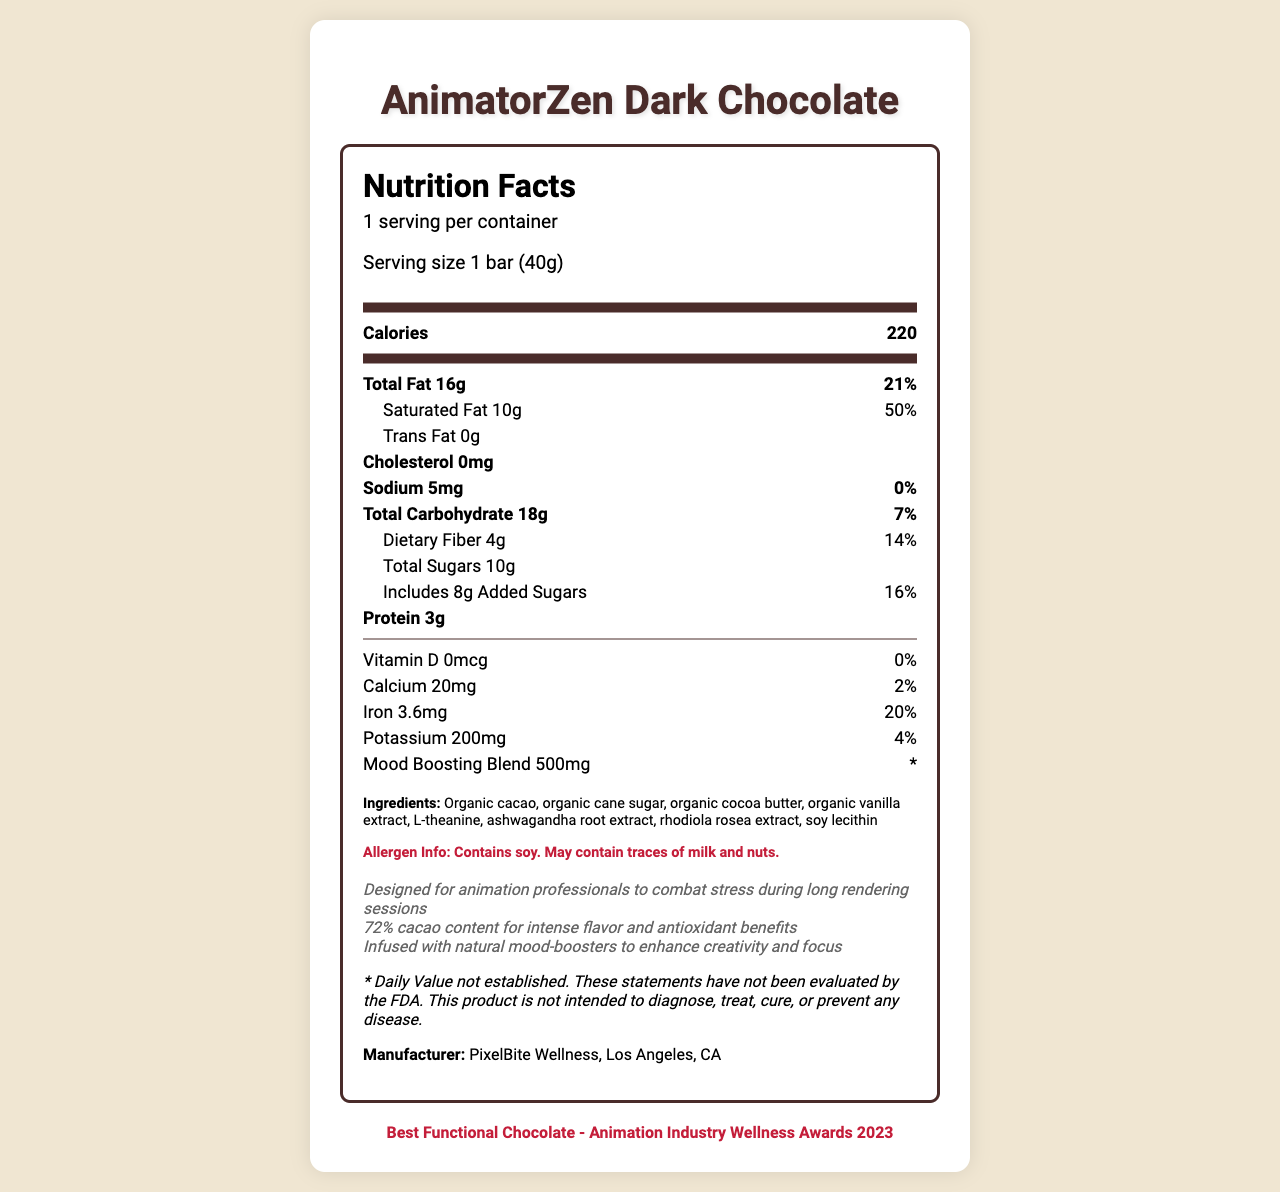what is the serving size of AnimatorZen Dark Chocolate? The serving size is clearly stated at the beginning of the document.
Answer: 1 bar (40g) how many calories does one serving of AnimatorZen Dark Chocolate contain? The document shows that each serving contains 220 calories.
Answer: 220 what is the total fat content per serving? The document specifies that the total fat content per serving is 16g.
Answer: 16g what percentage of the daily value does saturated fat contribute? It is highlighted in the document that the saturated fat contributes 50% to the daily value.
Answer: 50% what is the sodium content in AnimatorZen Dark Chocolate? The sodium content per serving is 5mg, according to the document.
Answer: 5mg what is the iron daily value percentage provided per serving? The document states that the iron content contributes 20% to the daily value.
Answer: 20% which ingredients in AnimatorZen Dark Chocolate are organic? A. Cacao B. Cane Sugar C. Cocoa Butter D. All of the above The ingredients list mentions that cacao, cane sugar, and cocoa butter are all organic.
Answer: D. All of the above what is the percentage of the daily value of calcium per serving? A. 10% B. 2% C. 5% D. 0% The document notes that the calcium content is 20mg, contributing 2% to the daily value.
Answer: B. 2% does AnimatorZen Dark Chocolate contain any trans fat? The document explicitly states that there is 0g of trans fat.
Answer: No is the product designed to combat stress during long rendering sessions? One of the special notes explicitly mentions that the product is designed for animation professionals to combat stress during long rendering sessions.
Answer: Yes what is the main purpose of AnimatorZen Dark Chocolate? The special notes highlight that the chocolate is infused with natural mood-boosters for stress relief and is designed for animation professionals.
Answer: The main purpose is to provide stress relief and enhance creativity and focus for animation professionals. what is the manufacturer's address for AnimatorZen Dark Chocolate? The document lists the manufacturer as PixelBite Wellness, Los Angeles, CA, but does not provide a specific address.
Answer: Not enough information describe the entire document The document extensively details the nutritional content and additional features of AnimatorZen Dark Chocolate, focusing on its health and mood benefits aimed at animation professionals.
Answer: The document is a detailed Nutrition Facts label for AnimatorZen Dark Chocolate, a specialty dark chocolate designed for animation professionals. The label includes serving size, calories, various nutritional components (fats, sodium, carbohydrates, proteins, vitamins, minerals), special ingredients like a mood-boosting blend, and allergen information. Special notes highlight its purpose to combat stress, enhance creativity, and its high cacao content for flavor and antioxidant benefits. It is manufactured by PixelBite Wellness and has won an award for best functional chocolate. 